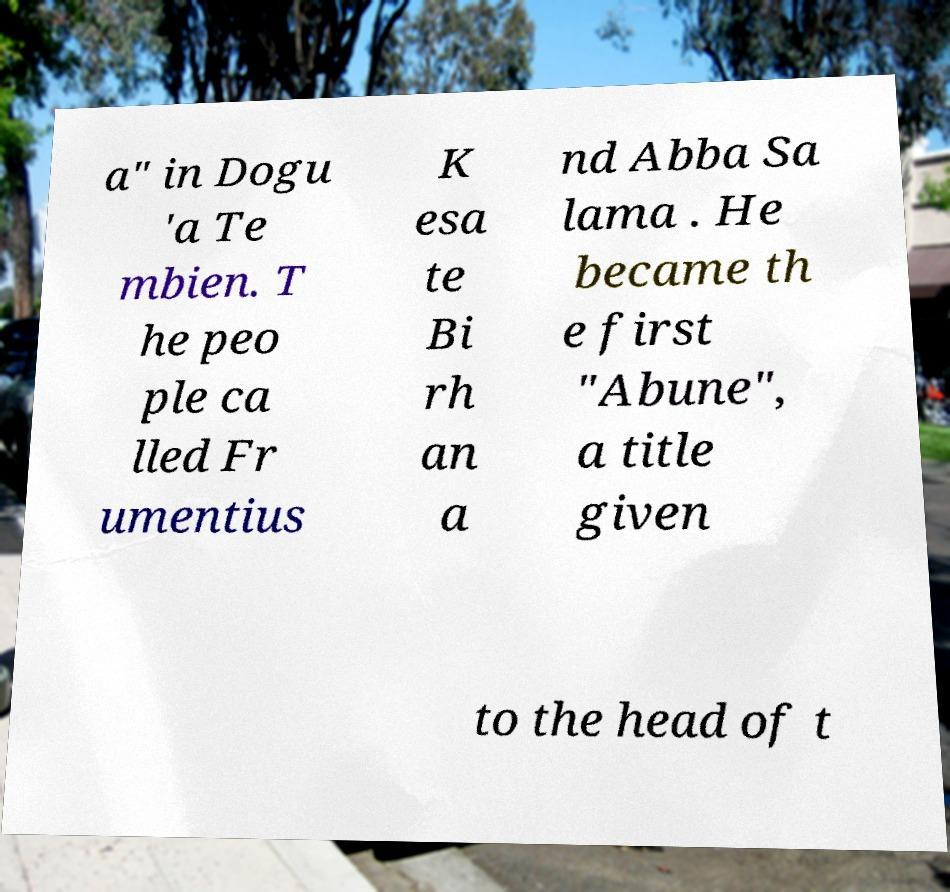There's text embedded in this image that I need extracted. Can you transcribe it verbatim? a" in Dogu 'a Te mbien. T he peo ple ca lled Fr umentius K esa te Bi rh an a nd Abba Sa lama . He became th e first "Abune", a title given to the head of t 